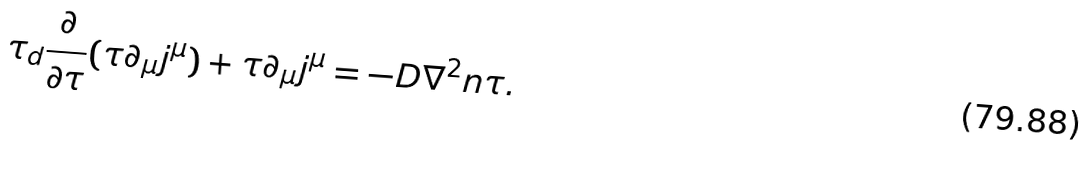Convert formula to latex. <formula><loc_0><loc_0><loc_500><loc_500>\tau _ { d } \frac { \partial } { \partial \tau } ( \tau \partial _ { \mu } j ^ { \mu } ) + \tau \partial _ { \mu } j ^ { \mu } = - D \nabla ^ { 2 } n \tau .</formula> 